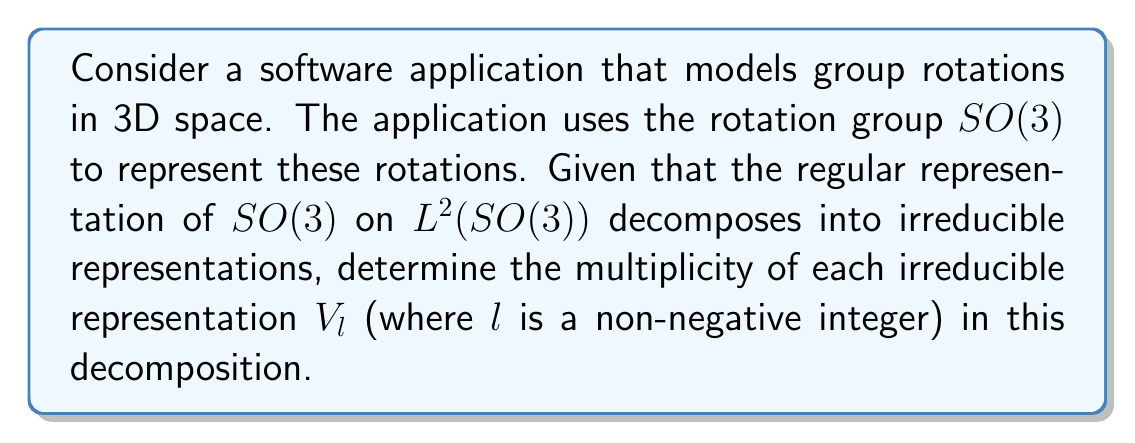Show me your answer to this math problem. To solve this problem, we'll follow these steps:

1) Recall that for compact Lie groups like $SO(3)$, the Peter-Weyl theorem applies. This theorem states that the regular representation decomposes into a direct sum of all irreducible representations, each appearing with multiplicity equal to its dimension.

2) For $SO(3)$, the irreducible representations are labeled by non-negative integers $l$, denoted as $V_l$. These are also known as the spherical harmonics.

3) The dimension of $V_l$ is given by $\dim(V_l) = 2l + 1$.

4) Therefore, in the decomposition of $L^2(SO(3))$, each $V_l$ appears with multiplicity $2l + 1$.

5) We can express this decomposition as:

   $$L^2(SO(3)) \cong \bigoplus_{l=0}^{\infty} (2l+1)V_l$$

   where $(2l+1)V_l$ denotes $2l+1$ copies of $V_l$.

6) In the context of the software application, this means that any function on $SO(3)$ (which could represent a rotation-dependent property in the 3D model) can be decomposed into these irreducible components, with each $V_l$ contributing $2l+1$ independent components.
Answer: $2l+1$ 